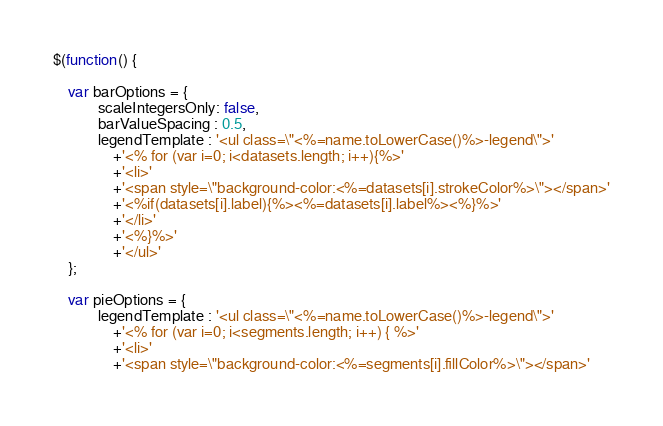Convert code to text. <code><loc_0><loc_0><loc_500><loc_500><_JavaScript_>
$(function() {

	var barOptions = {
	        scaleIntegersOnly: false,
	        barValueSpacing : 0.5,
	        legendTemplate : '<ul class=\"<%=name.toLowerCase()%>-legend\">'
	        	+'<% for (var i=0; i<datasets.length; i++){%>'
	        	+'<li>'
	        	+'<span style=\"background-color:<%=datasets[i].strokeColor%>\"></span>'
	        	+'<%if(datasets[i].label){%><%=datasets[i].label%><%}%>'
	        	+'</li>'
	        	+'<%}%>'
	        	+'</ul>'	        	
	};
	
	var pieOptions = {
			legendTemplate : '<ul class=\"<%=name.toLowerCase()%>-legend\">'
                +'<% for (var i=0; i<segments.length; i++) { %>'
                +'<li>'
                +'<span style=\"background-color:<%=segments[i].fillColor%>\"></span>'</code> 